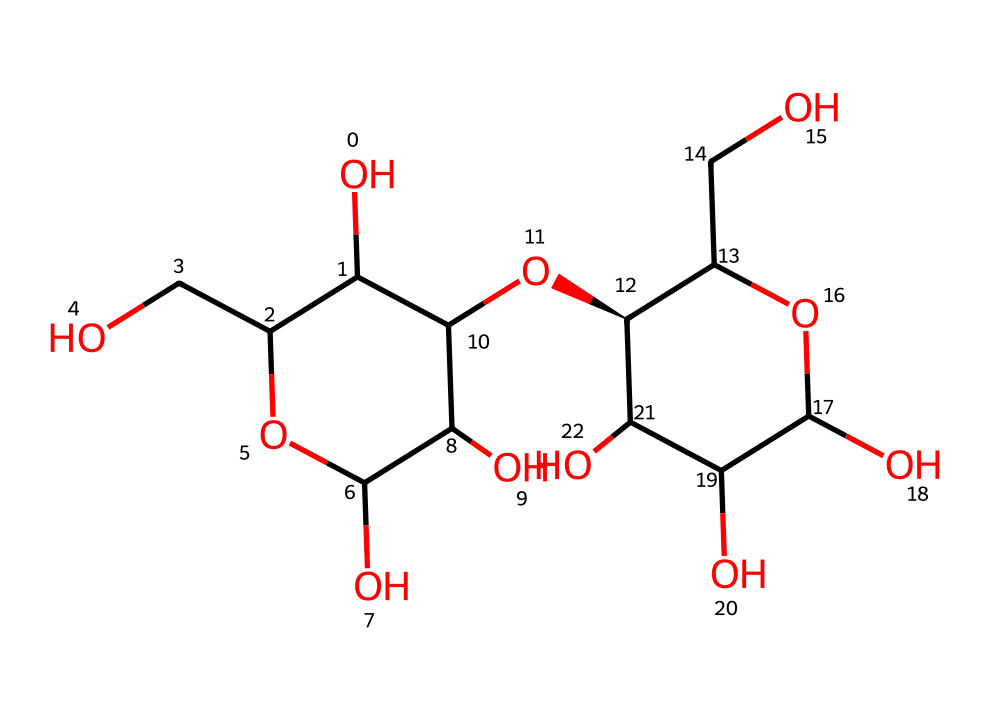How many carbon atoms are present in the structure? To determine the number of carbon atoms, we can analyze the SMILES representation for occurrences of 'C'. In the provided SMILES, there are multiple 'C' characters indicating that there are 12 carbon atoms present in total.
Answer: 12 What type of structure is represented by this SMILES? The structure indicated by the provided SMILES represents a polysaccharide, specifically a molecule similar to cellulose, as it consists of multiple hydroxyl (-OH) groups and carbon rings characteristic of carbohydrate structures.
Answer: polysaccharide How many hydroxyl groups are in this structure? To find the number of hydroxyl groups, we can look for occurrences of the hydroxyl (OH) moieties in the SMILES. In the structure, there are 6 hydroxyl groups indicated by the instances of '[OH]' and hydroxyl connections at various carbon atoms.
Answer: 6 Does this chemical structure suggest any polarity? Yes, the presence of multiple hydroxyl groups and the complex arrangement of atoms in the structure indicates that it is a polar compound due to the ability of the hydroxyl groups to form hydrogen bonds with water.
Answer: polar What can this chemical structure suggest about the potential for biodegradability? The structure, being composed mainly of carbon, hydrogen, and oxygen, with multiple hydroxyl groups, suggests that it is likely biodegradable as it resembles natural polysaccharides that are typically broken down by microorganisms in the environment.
Answer: biodegradable What type of bonding is predominantly featured in the structure represented? The structure contains mainly covalent bonds, as evidenced by the connections between carbon and oxygen atoms, as well as the carbon-carbon bonds which are characteristic of organic compounds.
Answer: covalent 